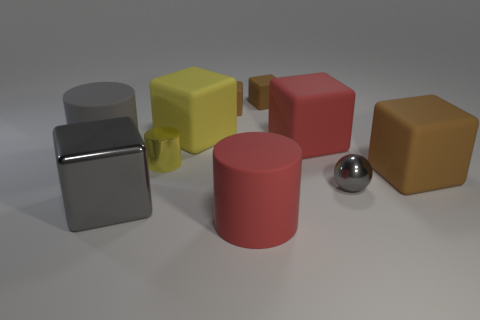Subtract all brown balls. How many brown cubes are left? 3 Subtract 2 cubes. How many cubes are left? 4 Subtract all red blocks. How many blocks are left? 5 Subtract all large gray blocks. How many blocks are left? 5 Subtract all yellow blocks. Subtract all red cylinders. How many blocks are left? 5 Subtract all balls. How many objects are left? 9 Subtract all blue objects. Subtract all gray cubes. How many objects are left? 9 Add 8 large metallic blocks. How many large metallic blocks are left? 9 Add 3 tiny yellow metallic objects. How many tiny yellow metallic objects exist? 4 Subtract 0 blue blocks. How many objects are left? 10 